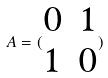Convert formula to latex. <formula><loc_0><loc_0><loc_500><loc_500>A = ( \begin{matrix} 0 & 1 \\ 1 & 0 \end{matrix} )</formula> 